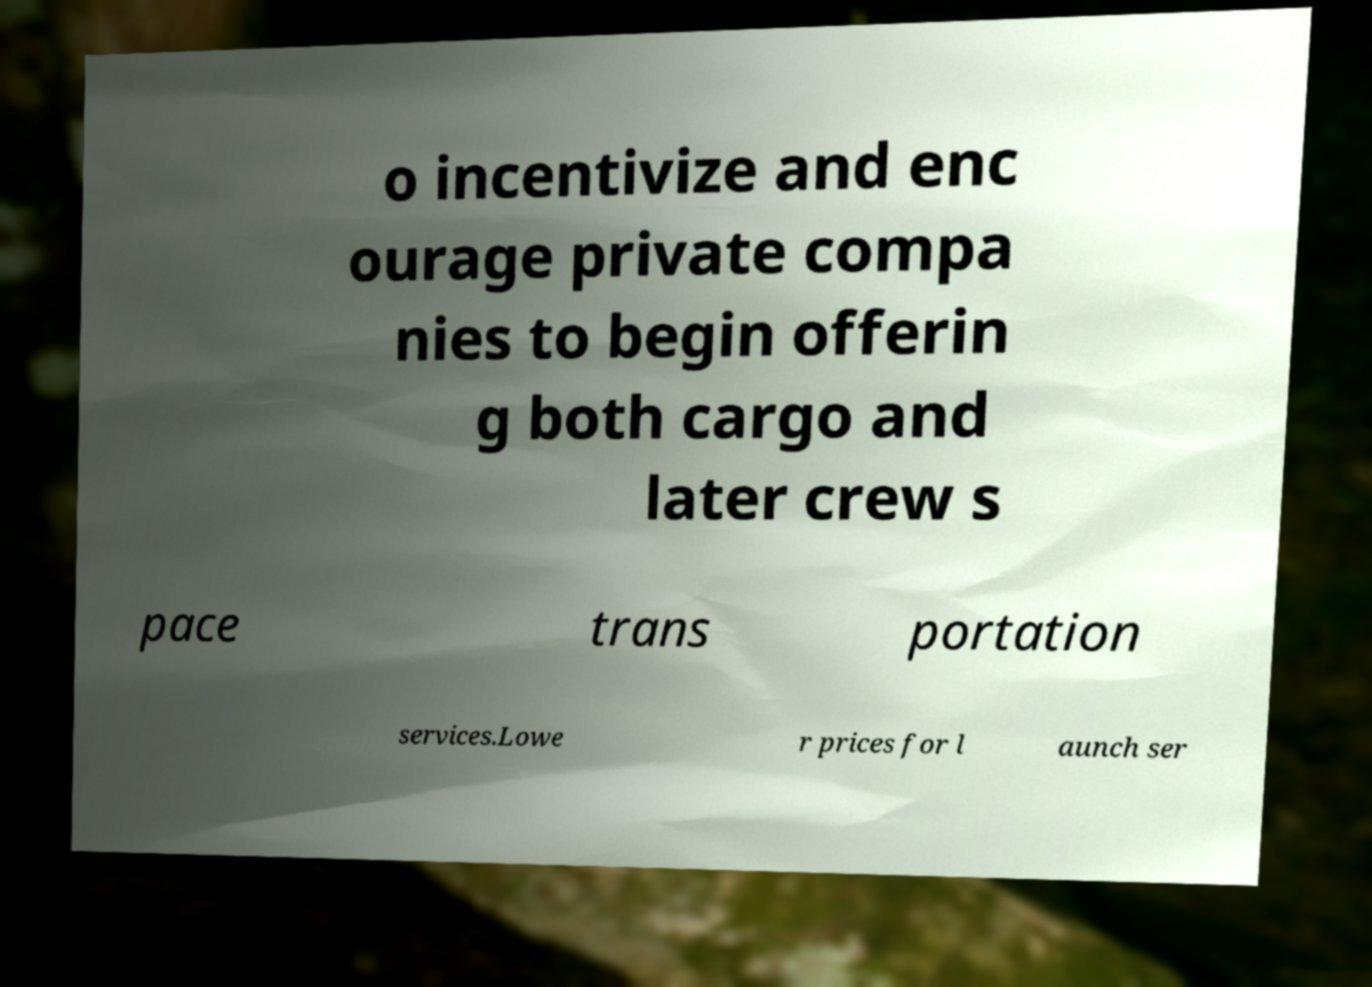Could you assist in decoding the text presented in this image and type it out clearly? o incentivize and enc ourage private compa nies to begin offerin g both cargo and later crew s pace trans portation services.Lowe r prices for l aunch ser 